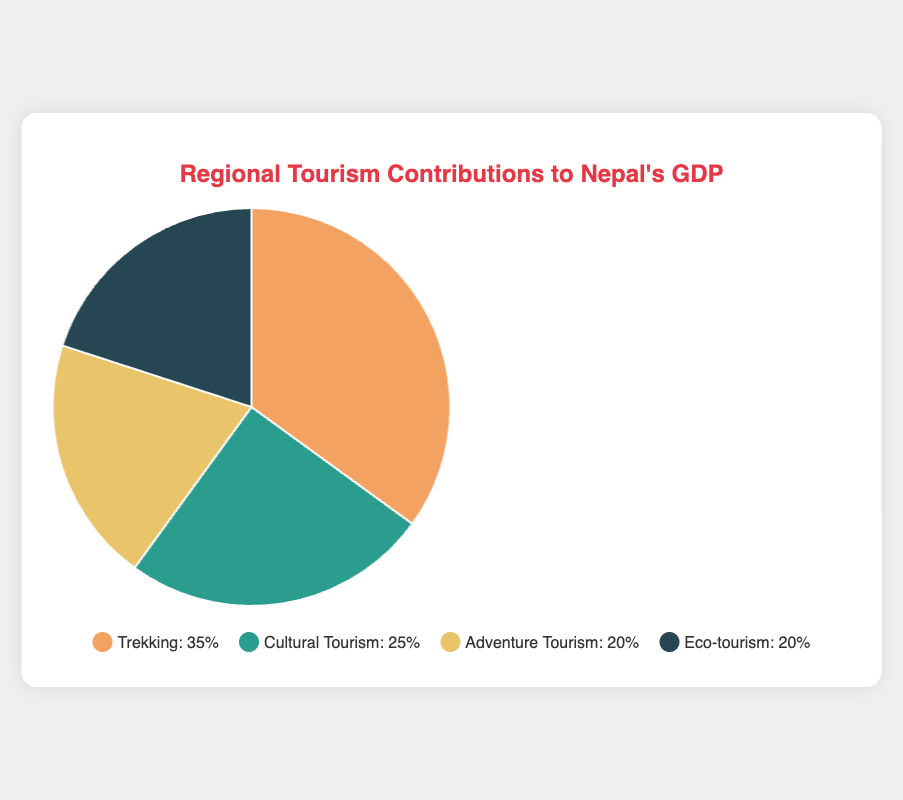What percentage of Nepal's GDP does trekking contribute to? The chart shows that trekking contributes 35% to Nepal's GDP.
Answer: 35% Which type of tourism has the smallest contribution to Nepal's GDP? The categories with the smallest contributions, eco-tourism and adventure tourism, are both at 20%, as shown by the chart segments of equal size.
Answer: Eco-tourism and Adventure Tourism Is the combined contribution of eco-tourism and adventure tourism more than the contribution of cultural tourism? The chart indicates that both eco-tourism and adventure tourism contribute 20% each. Therefore, the combined contribution is \(20% + 20% = 40%\), which is more than cultural tourism's 25%.
Answer: Yes How much more does trekking contribute to the GDP compared to adventure tourism? Trekking contributes 35%, while adventure tourism contributes 20%. The difference is \(35% - 20% = 15%\).
Answer: 15% Which segment in the pie chart is depicted with the largest area? The segment representing trekking is the largest, indicating a 35% contribution, which is the highest among all categories.
Answer: Trekking What is the average contribution of all tourism categories to Nepal's GDP? The total contribution is \(35% + 25% + 20% + 20% = 100%\). There are 4 categories, so the average is \(\frac{100%}{4} = 25%\).
Answer: 25% If another category, "Wildlife Tourism," were added and contributed 10%, how would the contributions adjust proportionally? If Wildlife Tourism is added, the total becomes 110%. The adjusted percentages are calculated as follows:
- Trekking:\(\frac{35}{110} \approx 31.8%\)
- Cultural Tourism:\(\frac{25}{110} \approx 22.7%\)
- Adventure Tourism:\(\frac{20}{110} \approx 18.2%\)
- Eco-tourism:\(\frac{20}{110} \approx 18.2%\)
- Wildlife Tourism: \(\frac{10}{110} \approx 9.1%\)
Answer: Adjustments needed Which categories contribute an equal percentage to Nepal's GDP, based on the chart? The chart shows that both eco-tourism and adventure tourism contribute 20% each to Nepal's GDP.
Answer: Eco-tourism and Adventure Tourism 